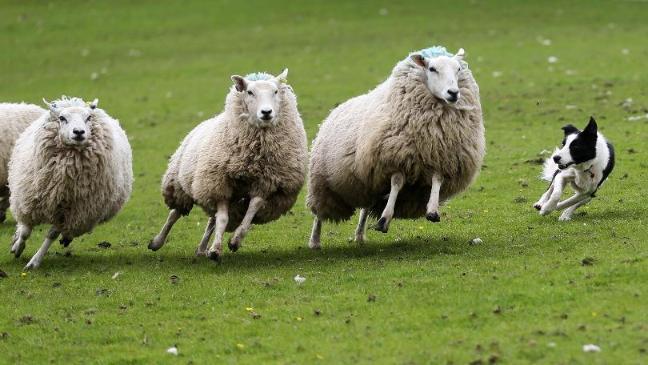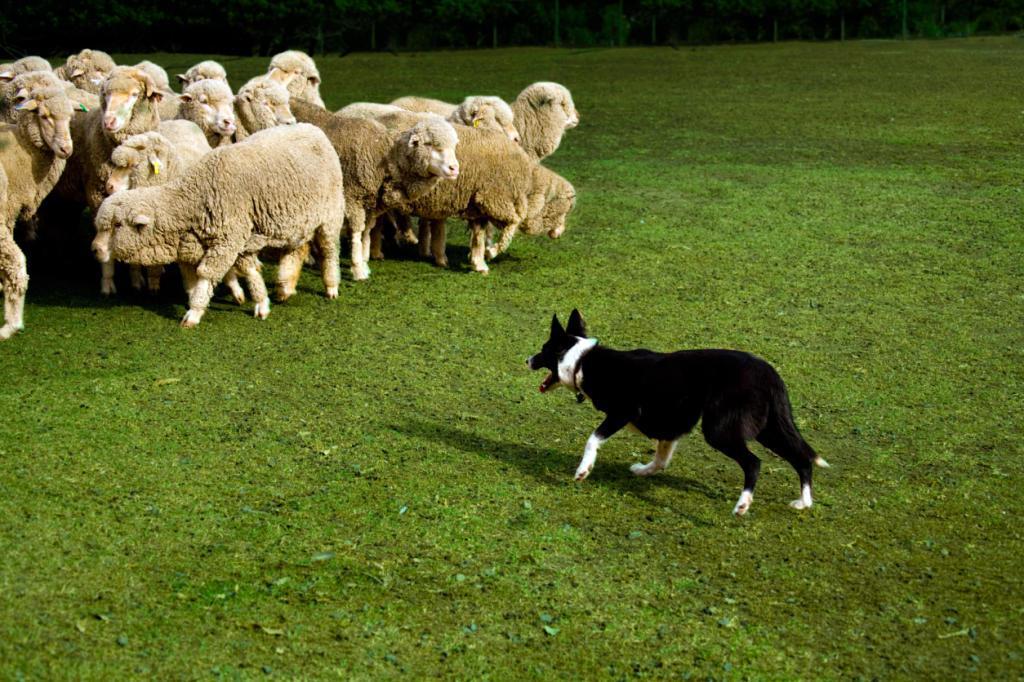The first image is the image on the left, the second image is the image on the right. Given the left and right images, does the statement "There are at least two dogs in the image on the left." hold true? Answer yes or no. No. The first image is the image on the left, the second image is the image on the right. Considering the images on both sides, is "Colored dye is visible on sheep's wool in the right image." valid? Answer yes or no. No. 